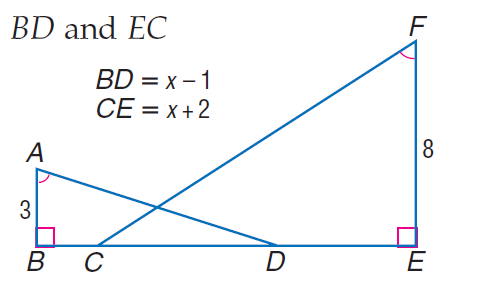Answer the mathemtical geometry problem and directly provide the correct option letter.
Question: Find B D.
Choices: A: 1.8 B: 2.4 C: 5 D: 6 A 